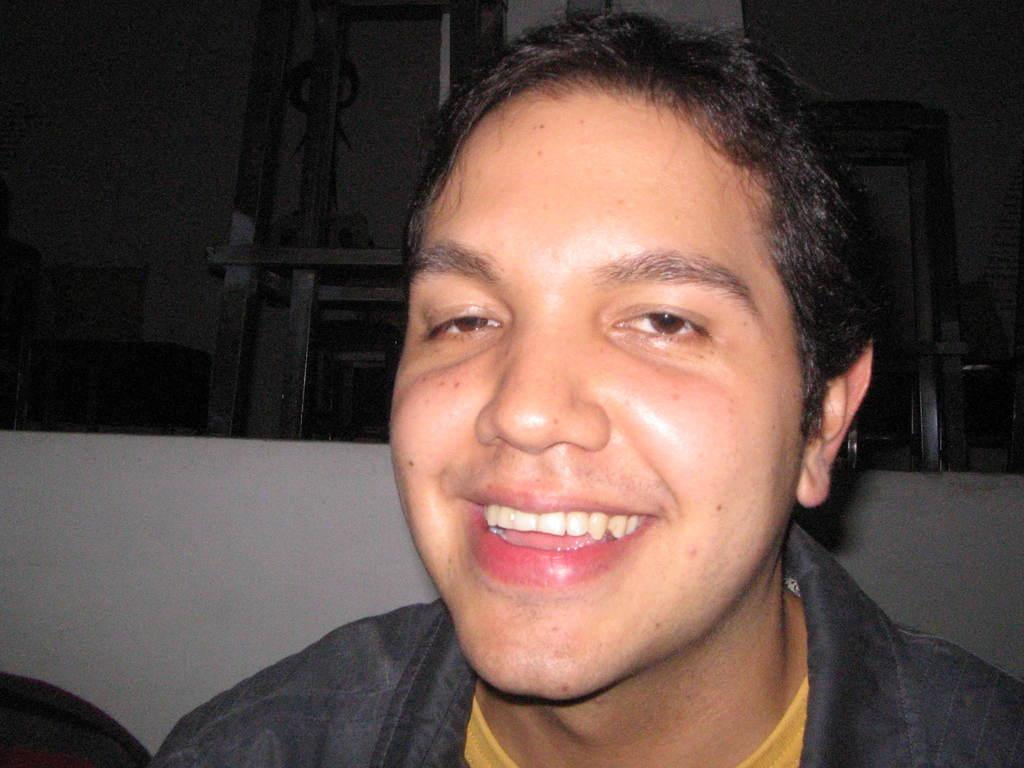Who is present in the image? There is a man in the image. What is the man's facial expression? The man is smiling. What can be seen in the background of the image? There are rods, a wall, and some objects in the background of the image. What type of reward is the man holding in the image? There is no reward visible in the image; the man is simply smiling. What activity is the man's thumb participating in within the image? The man's thumb is not participating in any activity within the image, as it is not mentioned or visible in the provided facts. 